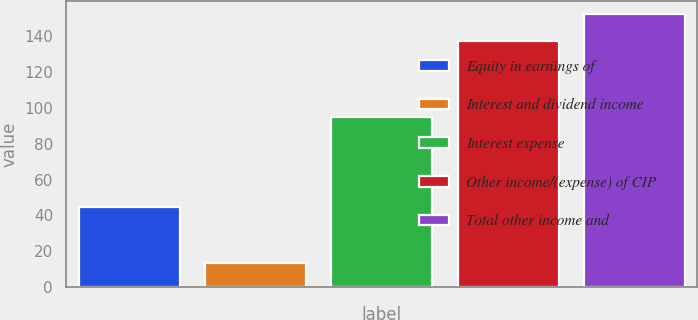Convert chart to OTSL. <chart><loc_0><loc_0><loc_500><loc_500><bar_chart><fcel>Equity in earnings of<fcel>Interest and dividend income<fcel>Interest expense<fcel>Other income/(expense) of CIP<fcel>Total other income and<nl><fcel>44.7<fcel>13.4<fcel>94.8<fcel>137.3<fcel>152.1<nl></chart> 